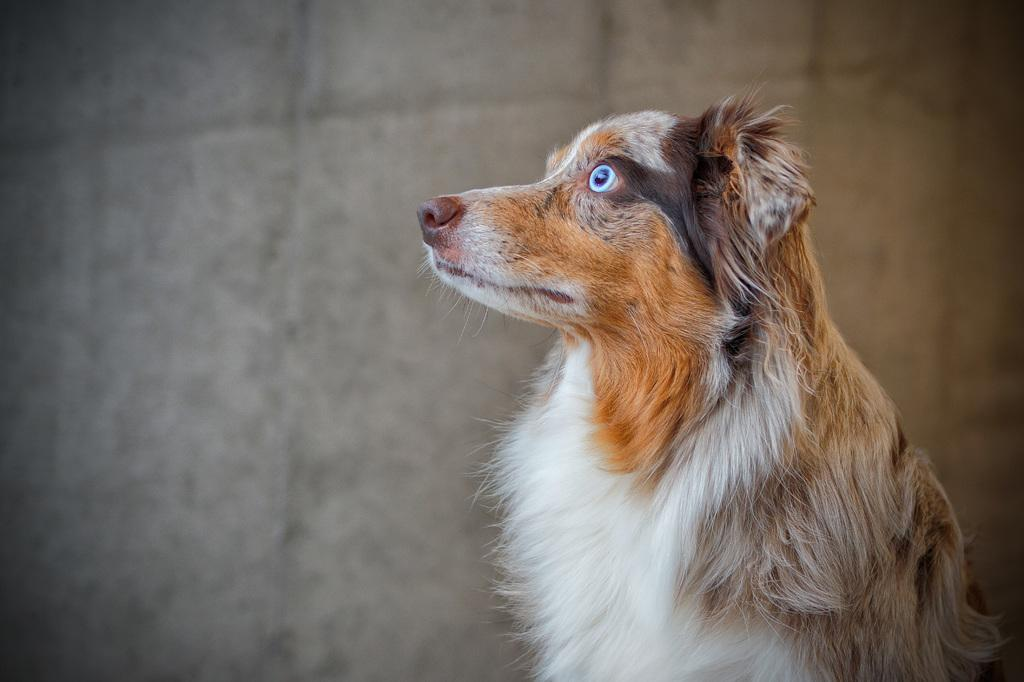What animal is present in the image? There is a dog in the image. Can you describe the color of the dog? The dog is brown and white in color. In which direction is the dog looking? The dog is looking to the left side. What type of smoke can be seen coming from the dog's mouth in the image? There is no smoke coming from the dog's mouth in the image. 